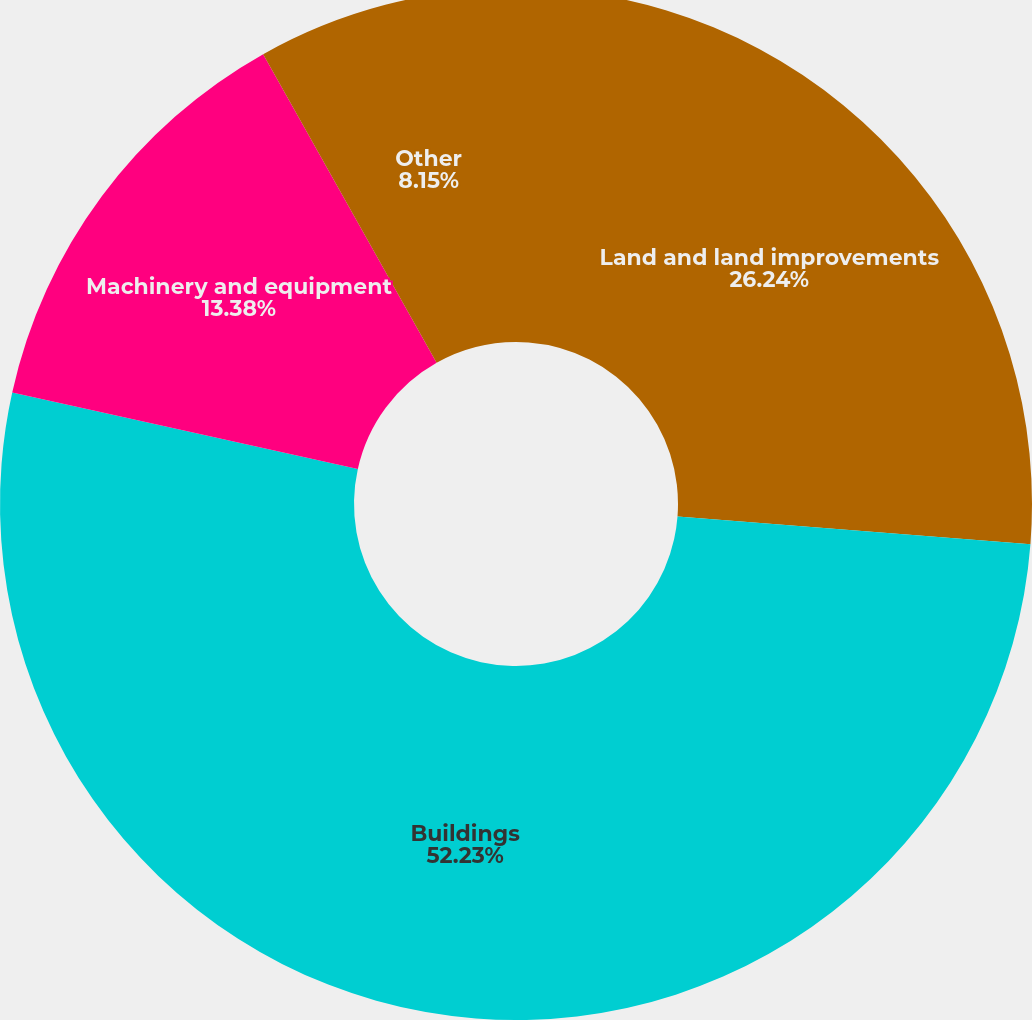Convert chart. <chart><loc_0><loc_0><loc_500><loc_500><pie_chart><fcel>Land and land improvements<fcel>Buildings<fcel>Machinery and equipment<fcel>Other<nl><fcel>26.24%<fcel>52.23%<fcel>13.38%<fcel>8.15%<nl></chart> 